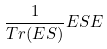<formula> <loc_0><loc_0><loc_500><loc_500>\frac { 1 } { T r ( E S ) } E S E</formula> 